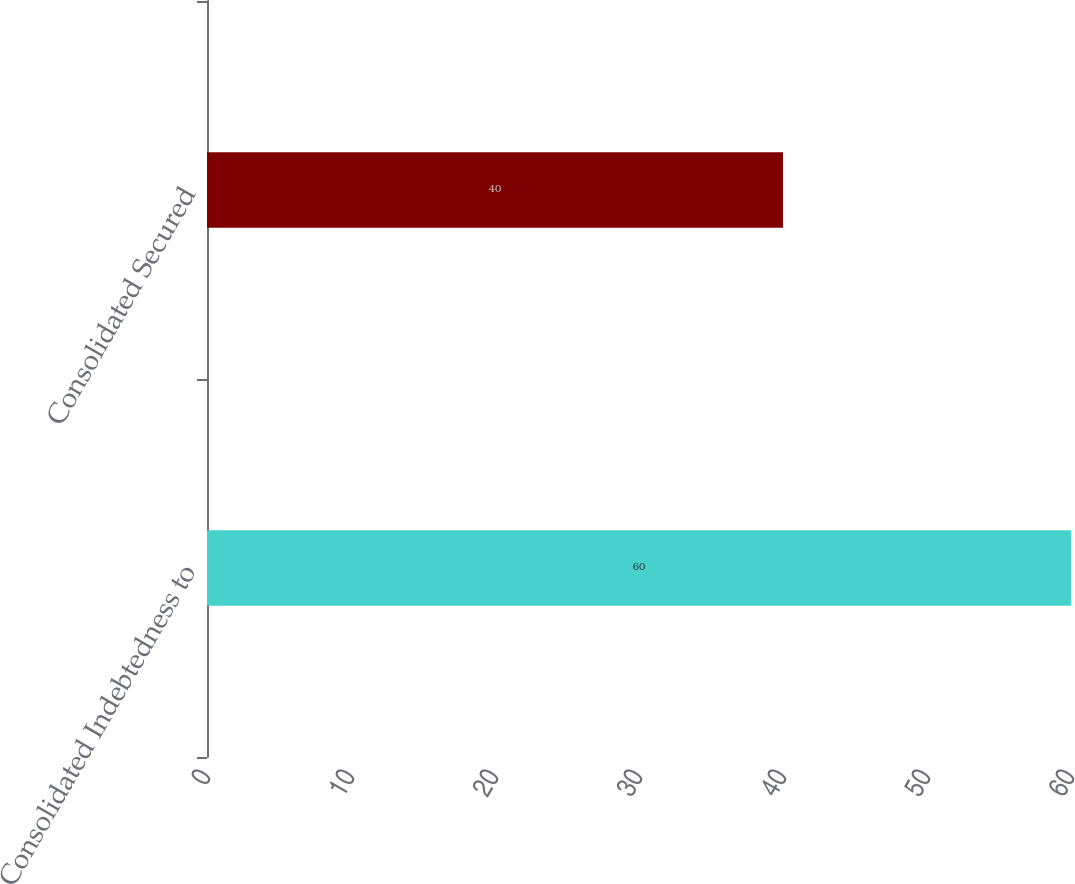<chart> <loc_0><loc_0><loc_500><loc_500><bar_chart><fcel>Consolidated Indebtedness to<fcel>Consolidated Secured<nl><fcel>60<fcel>40<nl></chart> 